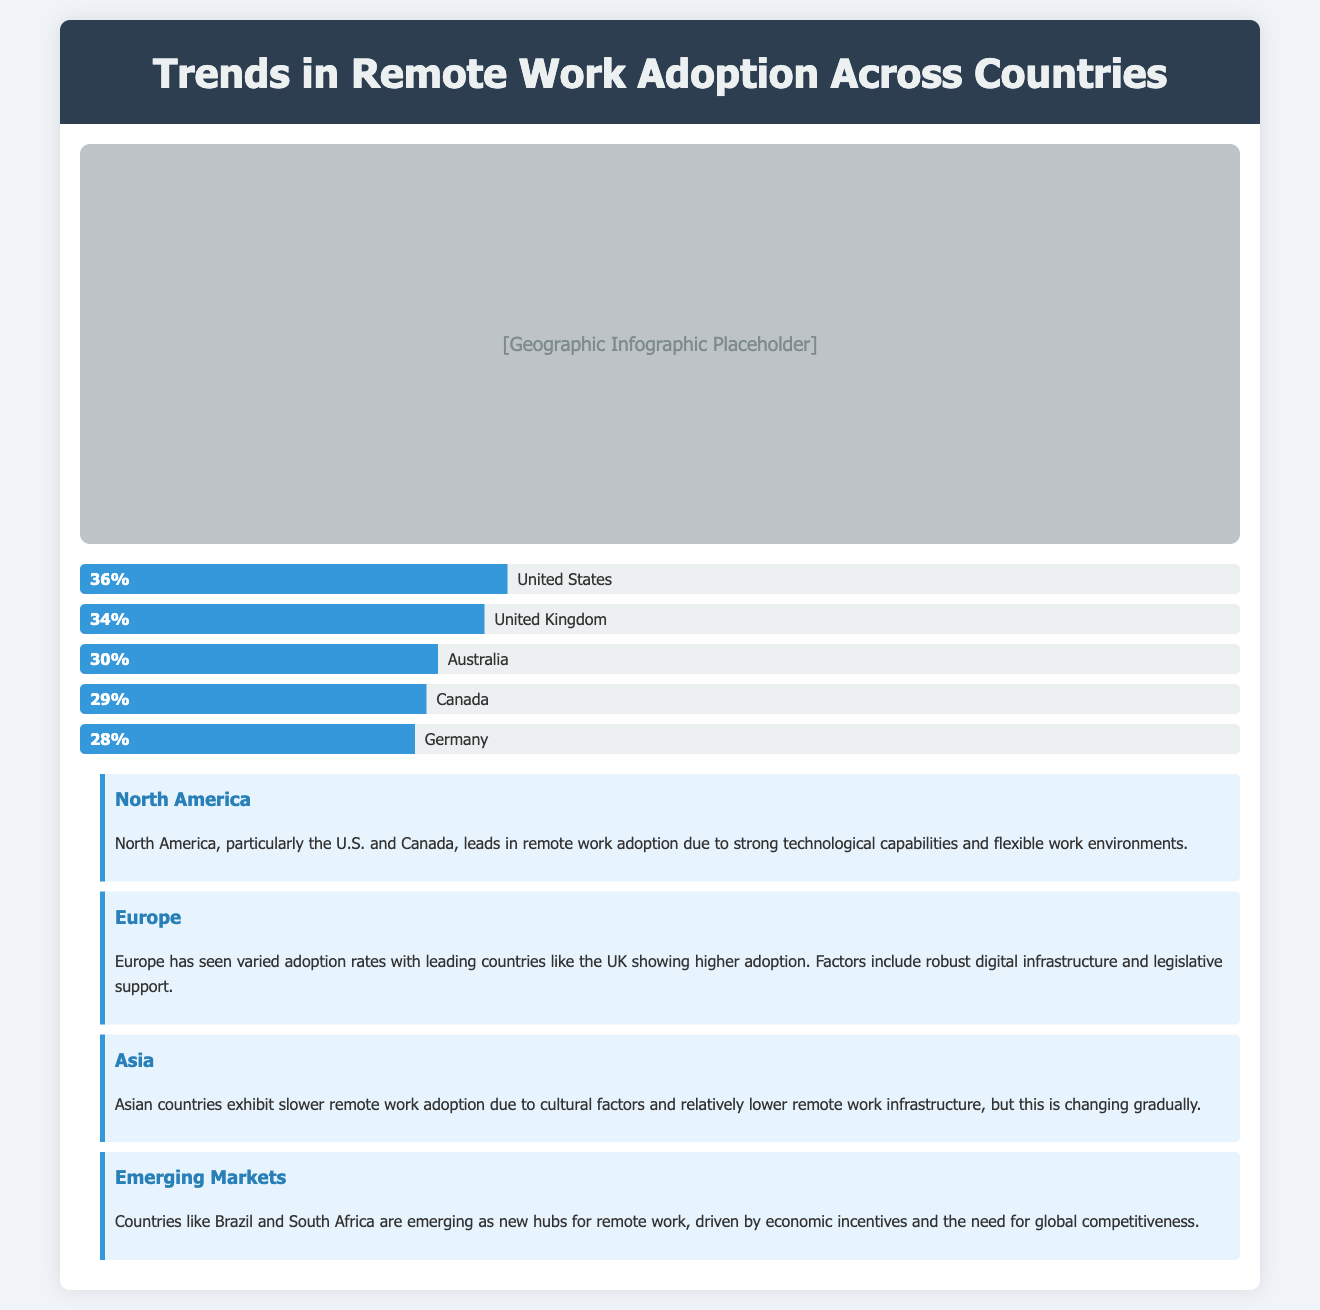what percentage of remote workers are in the United States? The percentage of remote workers in the United States as shown in the document is 36%.
Answer: 36% which country has the lowest percentage of remote workers? Among the listed countries, Germany has the lowest percentage at 28%.
Answer: Germany how many countries are shown in the bar chart? The bar chart displays five countries with their respective remote work percentages.
Answer: Five which region shows the highest remote work adoption? North America shows the highest remote work adoption, particularly the U.S. and Canada.
Answer: North America what factor contributes to Europe's higher adoption rates? Robust digital infrastructure and legislative support contribute to Europe's higher remote work adoption rates.
Answer: Digital infrastructure which emerging market is highlighted for remote work? Brazil is identified as an emerging market hub for remote work in the insights section.
Answer: Brazil how does remote work adoption in Asia compare to other regions? Remote work adoption in Asia is slower compared to North America and Europe.
Answer: Slower what is the main reason for remote work adoption in North America? Strong technological capabilities and flexible work environments drive remote work adoption in North America.
Answer: Technological capabilities which country follows the United Kingdom in remote work percentage? Australia follows the United Kingdom with a remote work percentage of 30%.
Answer: Australia 